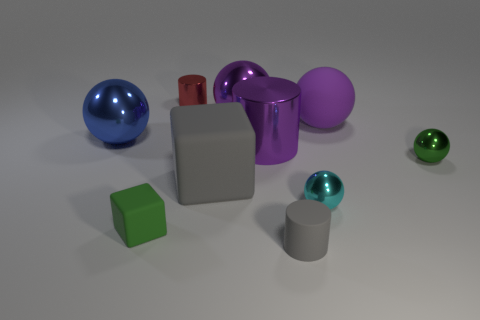There is a large purple object that is made of the same material as the small block; what is its shape?
Offer a very short reply. Sphere. Are there more small metal spheres in front of the matte cylinder than red objects?
Provide a succinct answer. No. What number of tiny cylinders are the same color as the big rubber sphere?
Your response must be concise. 0. What number of other things are the same color as the large metallic cylinder?
Make the answer very short. 2. Is the number of big blue things greater than the number of small cylinders?
Make the answer very short. No. What is the material of the red cylinder?
Your answer should be compact. Metal. There is a matte thing that is right of the gray matte cylinder; is it the same size as the red object?
Provide a short and direct response. No. There is a shiny ball that is right of the tiny cyan sphere; what is its size?
Offer a very short reply. Small. Are there any other things that have the same material as the tiny gray object?
Make the answer very short. Yes. What number of big blue cylinders are there?
Offer a very short reply. 0. 